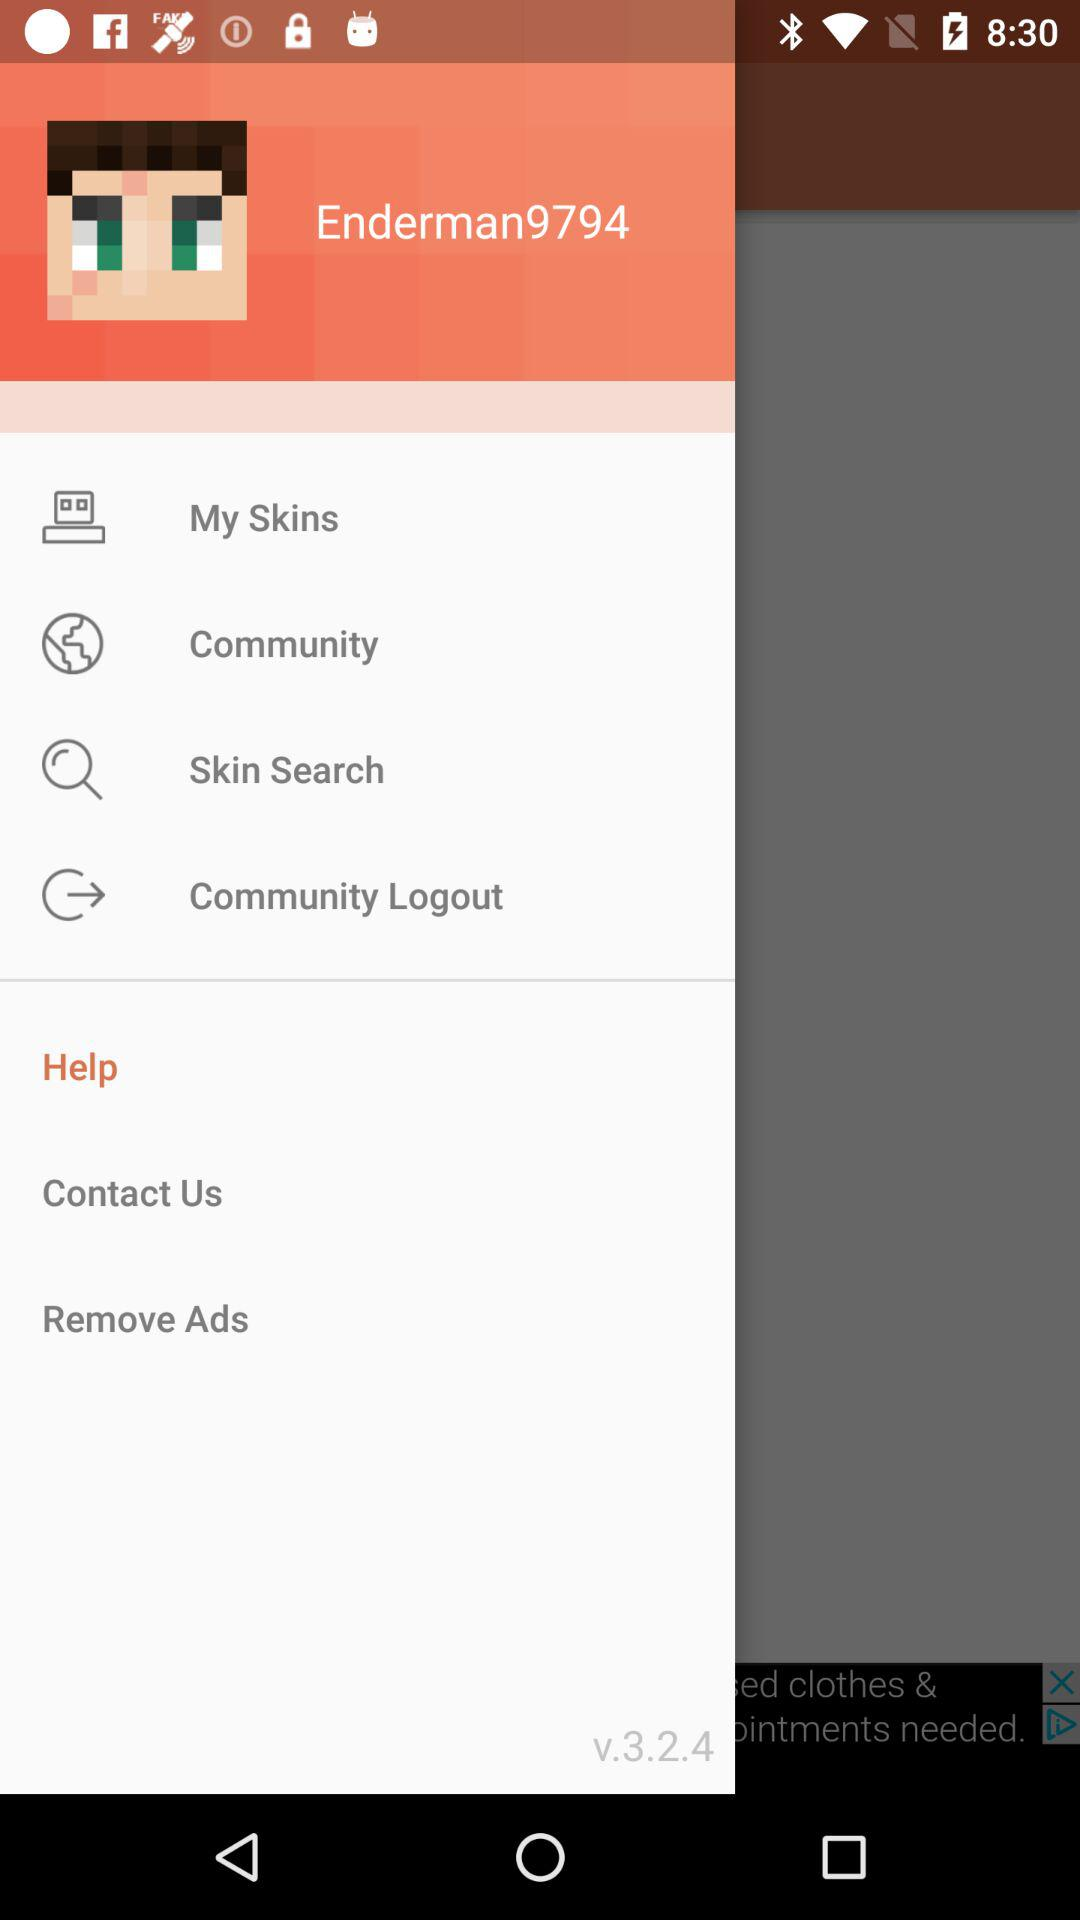What is the version of the app? The version number is v.3.2.4. 